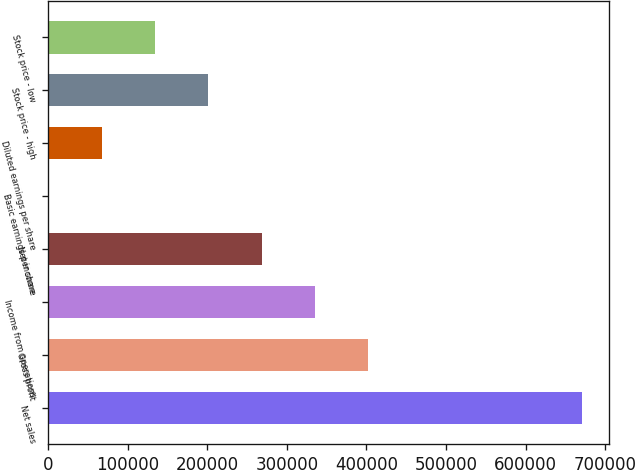Convert chart to OTSL. <chart><loc_0><loc_0><loc_500><loc_500><bar_chart><fcel>Net sales<fcel>Gross profit<fcel>Income from operations<fcel>Net income<fcel>Basic earnings per share<fcel>Diluted earnings per share<fcel>Stock price - high<fcel>Stock price - low<nl><fcel>670824<fcel>402495<fcel>335412<fcel>268330<fcel>0.42<fcel>67082.8<fcel>201248<fcel>134165<nl></chart> 